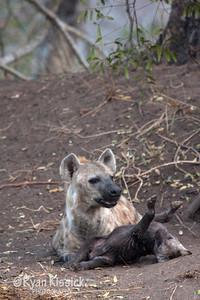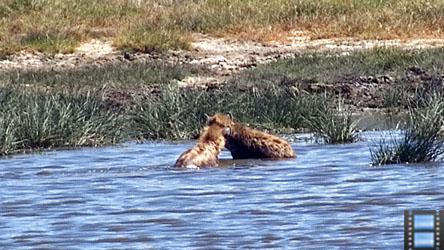The first image is the image on the left, the second image is the image on the right. Analyze the images presented: Is the assertion "Exactly one of the images shows hyenas in a wet area." valid? Answer yes or no. Yes. The first image is the image on the left, the second image is the image on the right. Analyze the images presented: Is the assertion "The left image contains one adult hyena and one baby hyena." valid? Answer yes or no. Yes. 